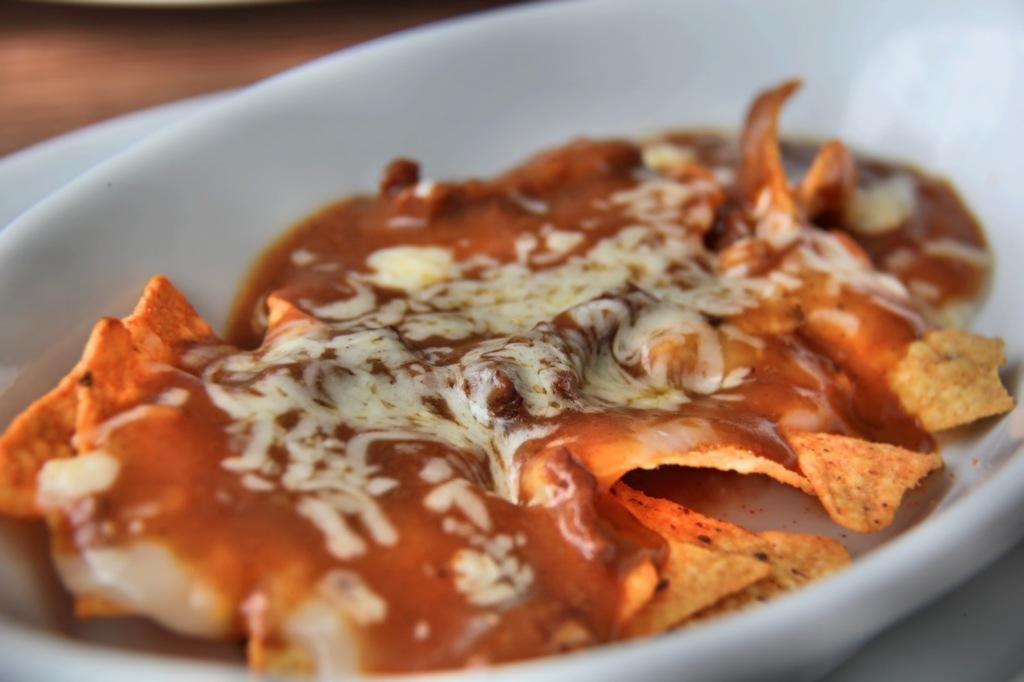What is the main subject of the image? There is a food item in the image. How is the food item presented in the image? The food item is placed in a bowl. What type of scarf is being used to stir the food in the image? There is no scarf present in the image, and the food is not being stirred. 